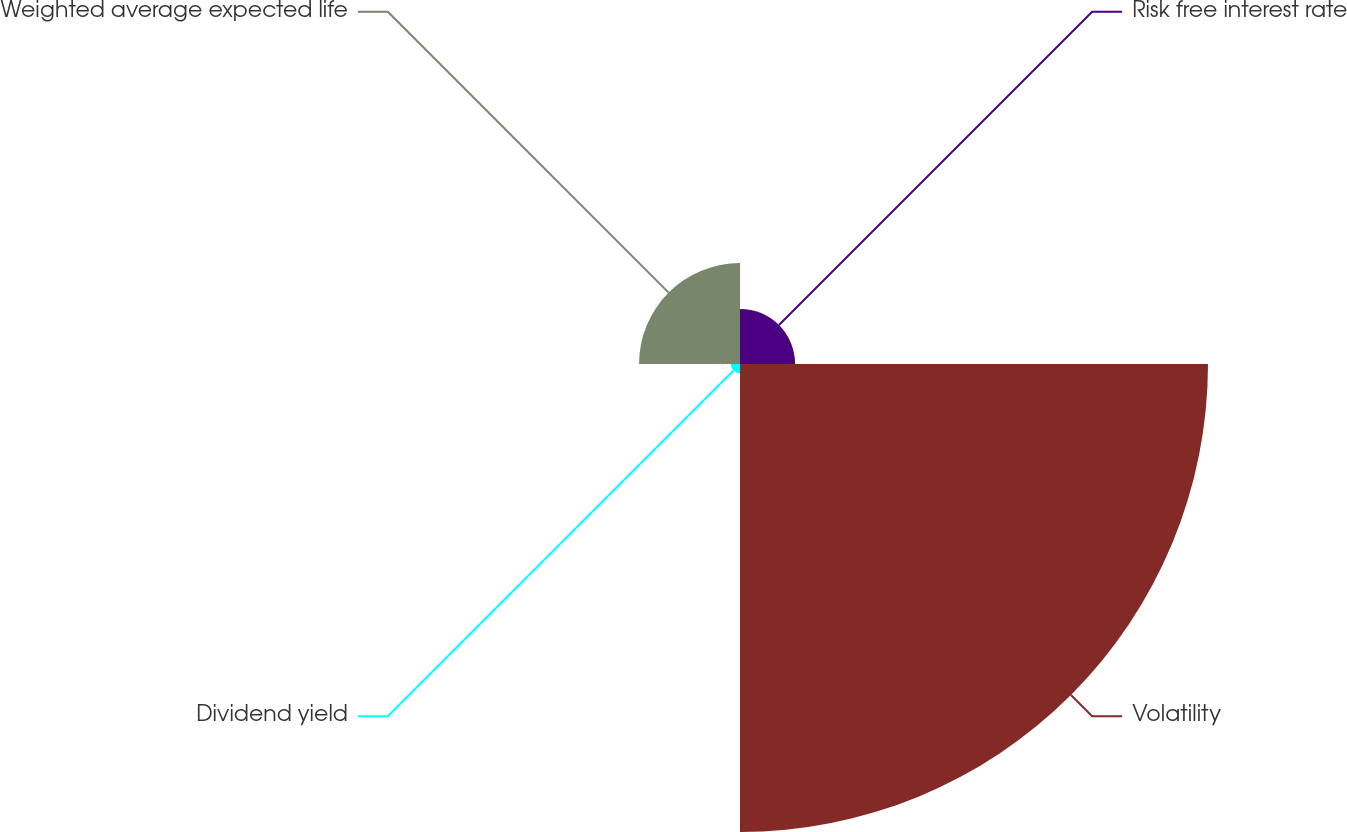<chart> <loc_0><loc_0><loc_500><loc_500><pie_chart><fcel>Risk free interest rate<fcel>Volatility<fcel>Dividend yield<fcel>Weighted average expected life<nl><fcel>8.7%<fcel>73.9%<fcel>1.45%<fcel>15.94%<nl></chart> 